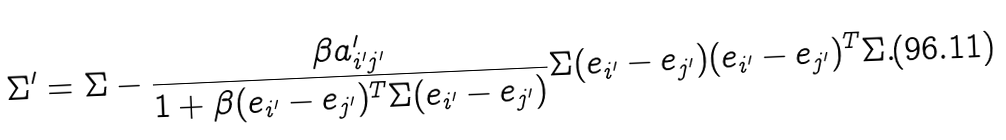Convert formula to latex. <formula><loc_0><loc_0><loc_500><loc_500>\Sigma ^ { \prime } = \Sigma - \frac { \beta a _ { i ^ { \prime } j ^ { \prime } } ^ { \prime } } { 1 + \beta ( e _ { i ^ { \prime } } - e _ { j ^ { \prime } } ) ^ { T } \Sigma ( e _ { i ^ { \prime } } - e _ { j ^ { \prime } } ) } \Sigma ( e _ { i ^ { \prime } } - e _ { j ^ { \prime } } ) ( e _ { i ^ { \prime } } - e _ { j ^ { \prime } } ) ^ { T } \Sigma .</formula> 